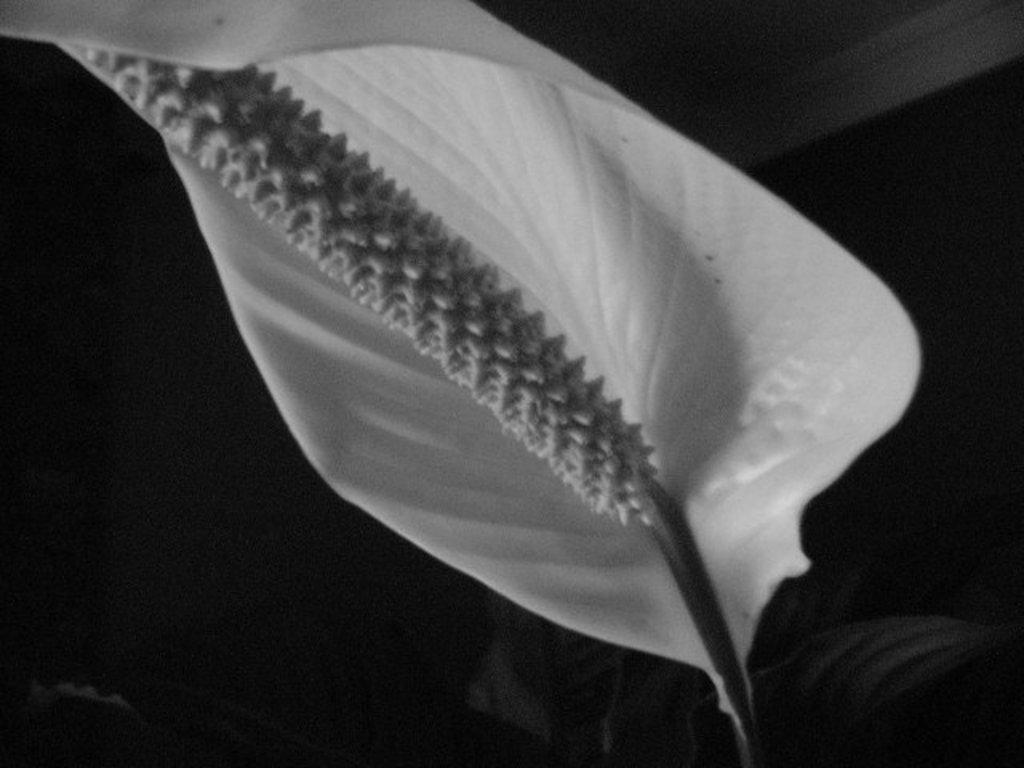What is the main subject of the image? The main subject of the image is a leaf. Can you describe the location of the leaf in the image? The leaf is in the center of the image. What type of discussion is taking place between the cats in the image? There are no cats present in the image, and therefore no discussion can be observed. Can you tell me how many volleyballs are visible in the image? There are no volleyballs present in the image. 